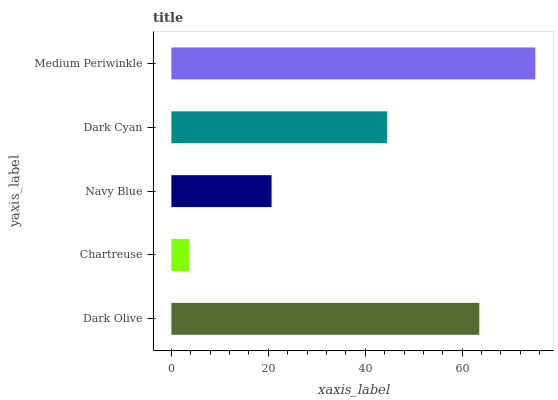Is Chartreuse the minimum?
Answer yes or no. Yes. Is Medium Periwinkle the maximum?
Answer yes or no. Yes. Is Navy Blue the minimum?
Answer yes or no. No. Is Navy Blue the maximum?
Answer yes or no. No. Is Navy Blue greater than Chartreuse?
Answer yes or no. Yes. Is Chartreuse less than Navy Blue?
Answer yes or no. Yes. Is Chartreuse greater than Navy Blue?
Answer yes or no. No. Is Navy Blue less than Chartreuse?
Answer yes or no. No. Is Dark Cyan the high median?
Answer yes or no. Yes. Is Dark Cyan the low median?
Answer yes or no. Yes. Is Navy Blue the high median?
Answer yes or no. No. Is Dark Olive the low median?
Answer yes or no. No. 